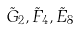Convert formula to latex. <formula><loc_0><loc_0><loc_500><loc_500>\tilde { G } _ { 2 } , \tilde { F } _ { 4 } , \tilde { E } _ { 8 }</formula> 